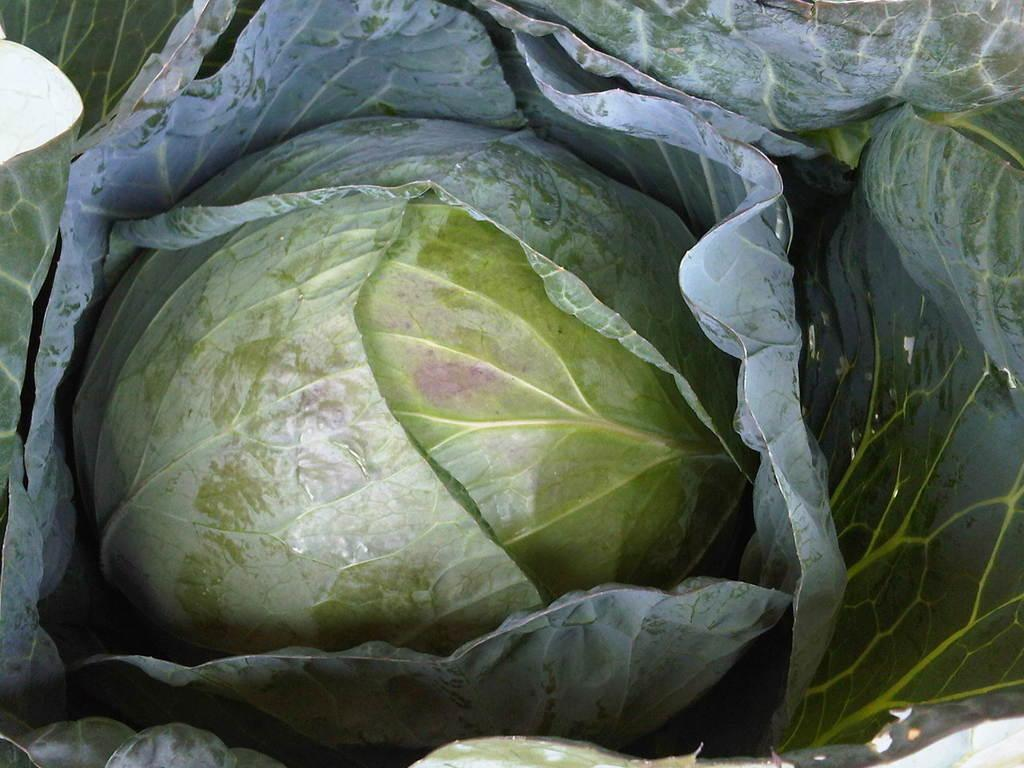What vegetable is present in the image? There is a cabbage in the image. What color are the leaves of the cabbage? The leaves of the cabbage are green. How many cherries are hanging from the cabbage in the image? There are no cherries present in the image; it only features a cabbage with green leaves. 